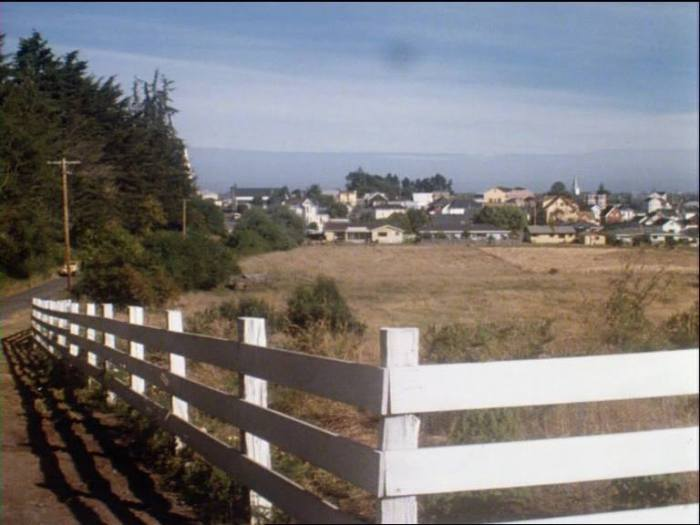What kind of ecosystem might this area support, considering the visible geographical features? Considering the visible geographical features, this area might support a diverse ecosystem. The proximity to a large body of water, likely a coastal bay, suggests marine and coastal ecosystems with species such as crabs, mollusks, various fish, and seabirds. The surrounding land, which appears to be a mixture of open fields and forested areas, might support a range of terrestrial species. These could include small mammals, birds, and various insects, as well as coastal vegetation like grasses, shrubs, and possibly some tree species adapted to windy, salty conditions. The presence of the town suggests potential human influence on the landscape, which might include agricultural activity, further enriching the biodiversity with plant crops and potentially livestock. 